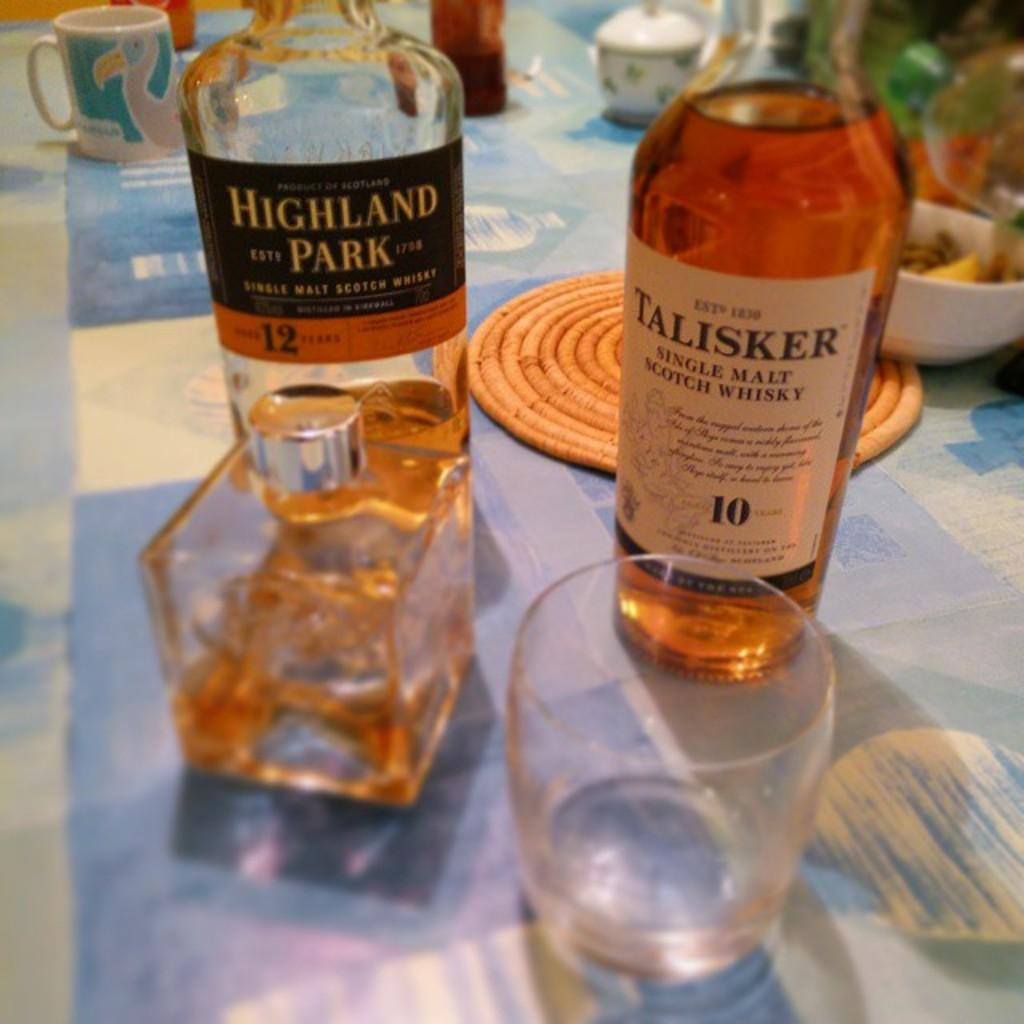What types of containers are visible in the image? There are bottles, glasses, cups, and a bowl in the image. Can you describe the different shapes and sizes of the containers? The containers in the image have various shapes and sizes, including tall and short bottles, wide and narrow glasses, and small and large cups. What might be the purpose of these containers? These containers might be used for holding or serving liquids or other items. Where is the mine located in the image? There is no mine present in the image; it only contains bottles, glasses, cups, and a bowl. 